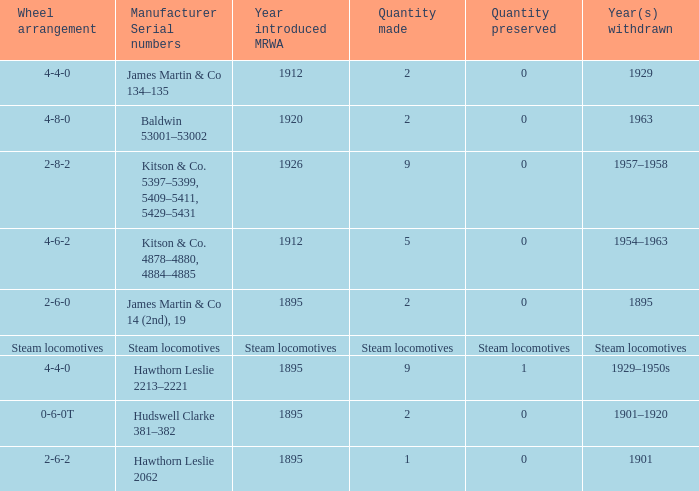What is the manufacturer serial number of the 1963 withdrawn year? Baldwin 53001–53002. Could you parse the entire table as a dict? {'header': ['Wheel arrangement', 'Manufacturer Serial numbers', 'Year introduced MRWA', 'Quantity made', 'Quantity preserved', 'Year(s) withdrawn'], 'rows': [['4-4-0', 'James Martin & Co 134–135', '1912', '2', '0', '1929'], ['4-8-0', 'Baldwin 53001–53002', '1920', '2', '0', '1963'], ['2-8-2', 'Kitson & Co. 5397–5399, 5409–5411, 5429–5431', '1926', '9', '0', '1957–1958'], ['4-6-2', 'Kitson & Co. 4878–4880, 4884–4885', '1912', '5', '0', '1954–1963'], ['2-6-0', 'James Martin & Co 14 (2nd), 19', '1895', '2', '0', '1895'], ['Steam locomotives', 'Steam locomotives', 'Steam locomotives', 'Steam locomotives', 'Steam locomotives', 'Steam locomotives'], ['4-4-0', 'Hawthorn Leslie 2213–2221', '1895', '9', '1', '1929–1950s'], ['0-6-0T', 'Hudswell Clarke 381–382', '1895', '2', '0', '1901–1920'], ['2-6-2', 'Hawthorn Leslie 2062', '1895', '1', '0', '1901']]} 